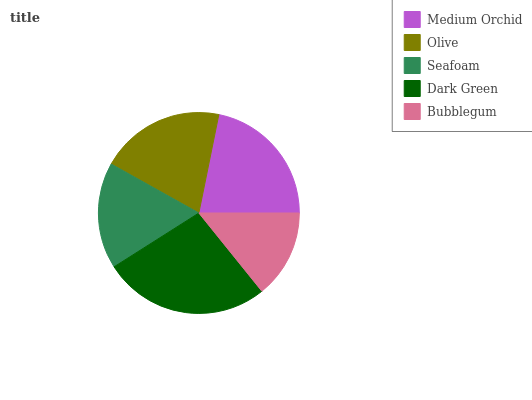Is Bubblegum the minimum?
Answer yes or no. Yes. Is Dark Green the maximum?
Answer yes or no. Yes. Is Olive the minimum?
Answer yes or no. No. Is Olive the maximum?
Answer yes or no. No. Is Medium Orchid greater than Olive?
Answer yes or no. Yes. Is Olive less than Medium Orchid?
Answer yes or no. Yes. Is Olive greater than Medium Orchid?
Answer yes or no. No. Is Medium Orchid less than Olive?
Answer yes or no. No. Is Olive the high median?
Answer yes or no. Yes. Is Olive the low median?
Answer yes or no. Yes. Is Bubblegum the high median?
Answer yes or no. No. Is Medium Orchid the low median?
Answer yes or no. No. 